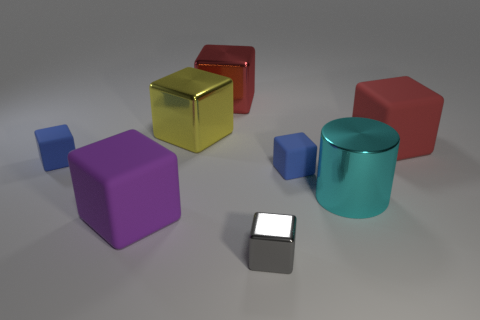Subtract all tiny gray metal blocks. How many blocks are left? 6 Subtract all blocks. How many objects are left? 1 Add 3 big cylinders. How many big cylinders exist? 4 Add 1 blue matte cubes. How many objects exist? 9 Subtract all red blocks. How many blocks are left? 5 Subtract 0 blue cylinders. How many objects are left? 8 Subtract 7 blocks. How many blocks are left? 0 Subtract all red cylinders. Subtract all gray balls. How many cylinders are left? 1 Subtract all blue cylinders. How many yellow cubes are left? 1 Subtract all large yellow metal blocks. Subtract all big purple cubes. How many objects are left? 6 